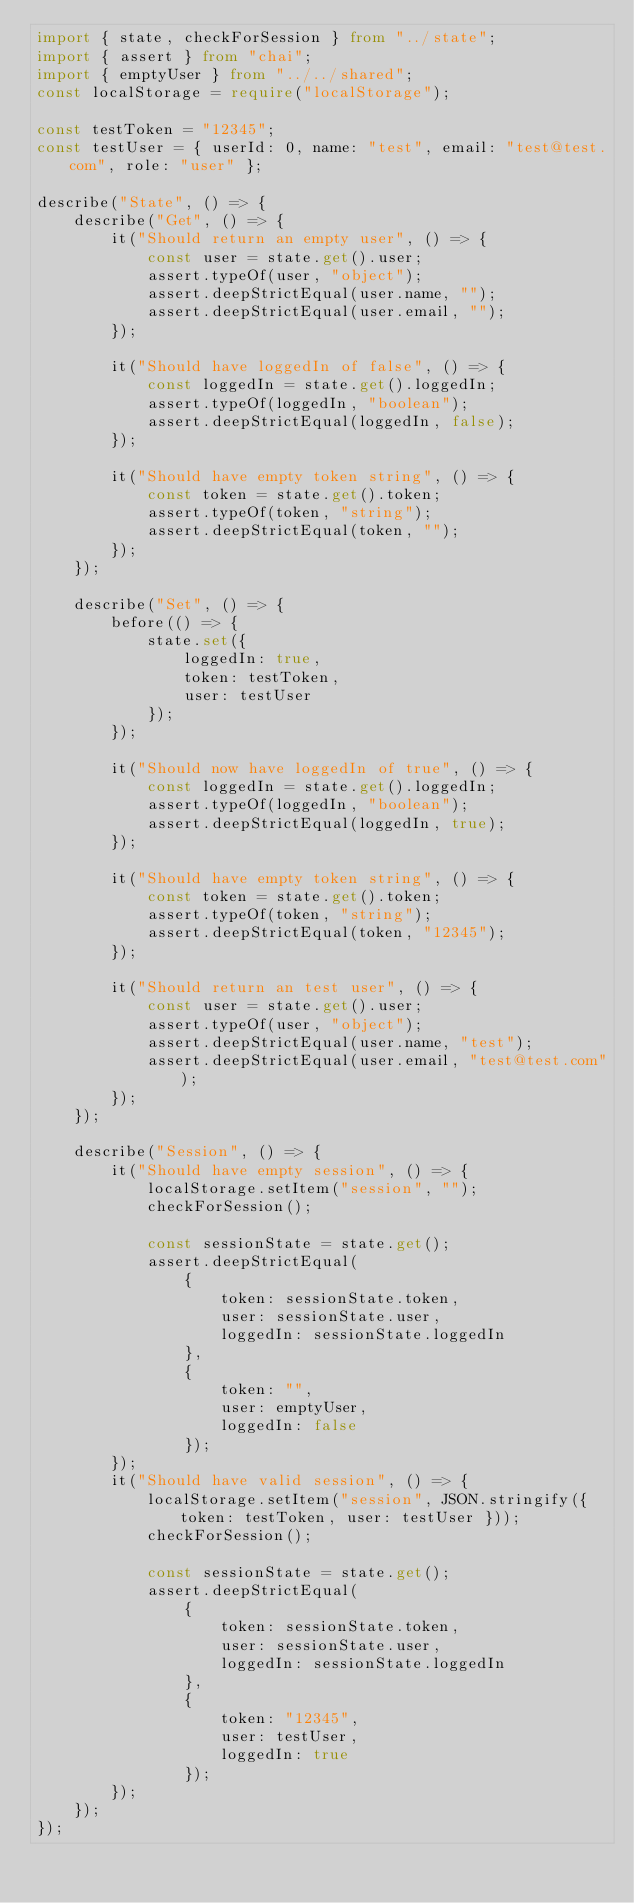<code> <loc_0><loc_0><loc_500><loc_500><_TypeScript_>import { state, checkForSession } from "../state";
import { assert } from "chai";
import { emptyUser } from "../../shared";
const localStorage = require("localStorage");

const testToken = "12345";
const testUser = { userId: 0, name: "test", email: "test@test.com", role: "user" };

describe("State", () => {
    describe("Get", () => {
        it("Should return an empty user", () => {
            const user = state.get().user;
            assert.typeOf(user, "object");
            assert.deepStrictEqual(user.name, "");
            assert.deepStrictEqual(user.email, "");
        });

        it("Should have loggedIn of false", () => {
            const loggedIn = state.get().loggedIn;
            assert.typeOf(loggedIn, "boolean");
            assert.deepStrictEqual(loggedIn, false);
        });

        it("Should have empty token string", () => {
            const token = state.get().token;
            assert.typeOf(token, "string");
            assert.deepStrictEqual(token, "");
        });
    });

    describe("Set", () => {
        before(() => {
            state.set({
                loggedIn: true,
                token: testToken,
                user: testUser
            });
        });

        it("Should now have loggedIn of true", () => {
            const loggedIn = state.get().loggedIn;
            assert.typeOf(loggedIn, "boolean");
            assert.deepStrictEqual(loggedIn, true);
        });

        it("Should have empty token string", () => {
            const token = state.get().token;
            assert.typeOf(token, "string");
            assert.deepStrictEqual(token, "12345");
        });

        it("Should return an test user", () => {
            const user = state.get().user;
            assert.typeOf(user, "object");
            assert.deepStrictEqual(user.name, "test");
            assert.deepStrictEqual(user.email, "test@test.com");
        });
    });

    describe("Session", () => {
        it("Should have empty session", () => {
            localStorage.setItem("session", "");
            checkForSession();

            const sessionState = state.get();
            assert.deepStrictEqual(
                {
                    token: sessionState.token,
                    user: sessionState.user,
                    loggedIn: sessionState.loggedIn
                },
                {
                    token: "",
                    user: emptyUser,
                    loggedIn: false
                });
        });
        it("Should have valid session", () => {
            localStorage.setItem("session", JSON.stringify({ token: testToken, user: testUser }));
            checkForSession();

            const sessionState = state.get();
            assert.deepStrictEqual(
                {
                    token: sessionState.token,
                    user: sessionState.user,
                    loggedIn: sessionState.loggedIn
                },
                {
                    token: "12345",
                    user: testUser,
                    loggedIn: true
                });
        });
    });
});
</code> 